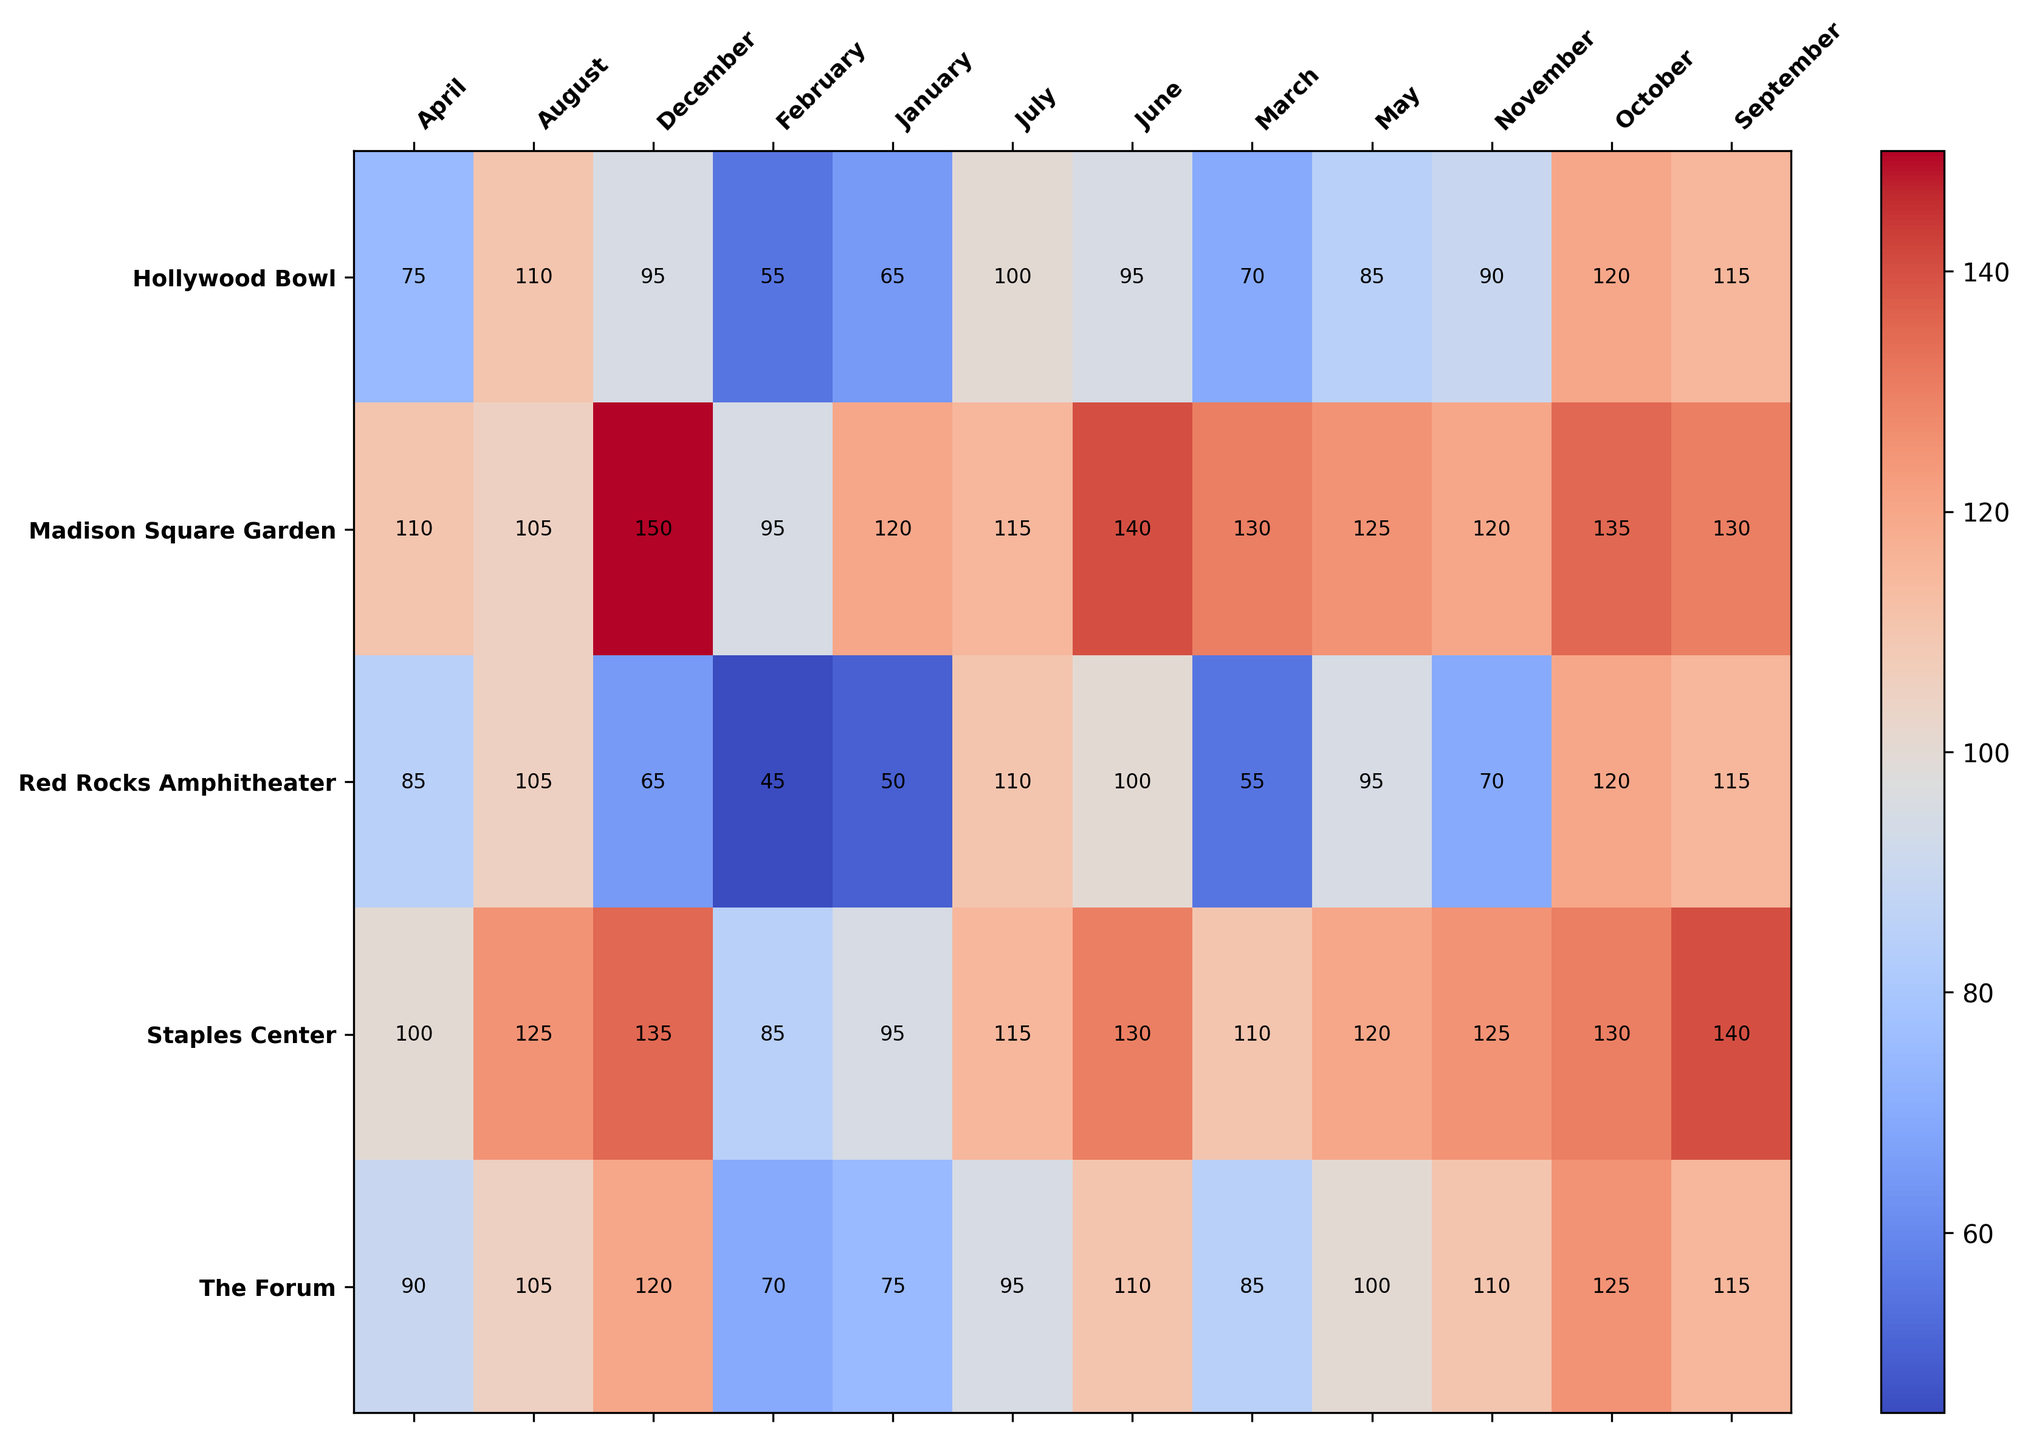Which venue has the highest booking frequency in December? Looking at the heatmap, check the December column and identify the highest numerical value. Madison Square Garden has the highest booking frequency of 150 in December.
Answer: Madison Square Garden Which venue had the lowest booking frequency in January? Looking at the heatmap, check the January column and identify the lowest numerical value. Red Rocks Amphitheater had the lowest booking frequency of 50 in January.
Answer: Red Rocks Amphitheater What is the average booking frequency for Hollywood Bowl in the summer months (June, July, August)? Identify the booking frequencies for Hollywood Bowl in June (95), July (100), and August (110). Add them up and divide by 3. (95 + 100 + 110) / 3 = 305 / 3 = 101.67
Answer: 101.67 Which venue has the most consistent booking frequency throughout the year? By observing the heatmap, the venue with the least variation in color intensity year-round is Staples Center.
Answer: Staples Center What is the combined booking frequency for The Forum and Hollywood Bowl in May? Identify the booking frequencies for both The Forum (100) and Hollywood Bowl (85) in May. Add them up. 100 + 85 = 185
Answer: 185 During which month does Red Rocks Amphitheater see a significant increase in booking frequency compared to the previous month? Looking at the heatmap, check for a noticeable jump in values for Red Rocks Amphitheater. April sees a jump to 85 from March's 55, an increase of 30.
Answer: April Compare the booking frequencies at Madison Square Garden and Staples Center in June. Which venue has a higher frequency and what is the difference? Identify the June frequencies for both venues: Madison Square Garden (140) and Staples Center (130). Madison Square Garden has a higher frequency by 140 - 130 = 10.
Answer: Madison Square Garden, 10 What is the difference in booking frequency between Red Rocks Amphitheater and Hollywood Bowl in October? Identify the October frequencies for both venues: Red Rocks Amphitheater (120) and Hollywood Bowl (120). The difference is 120 - 120 = 0.
Answer: 0 Which venue has the highest booking frequency in the month of October? Looking at the heatmap, check the October column and identify the highest numerical value. Madison Square Garden has the highest frequency of 135 in October.
Answer: Madison Square Garden What is the total booking frequency across all venues in August? Sum up the frequencies for all venues in August. Madison Square Garden (105), Staples Center (125), Red Rocks Amphitheater (105), The Forum (105), Hollywood Bowl (110). Total is 105 + 125 + 105 + 105 + 110 = 550.
Answer: 550 